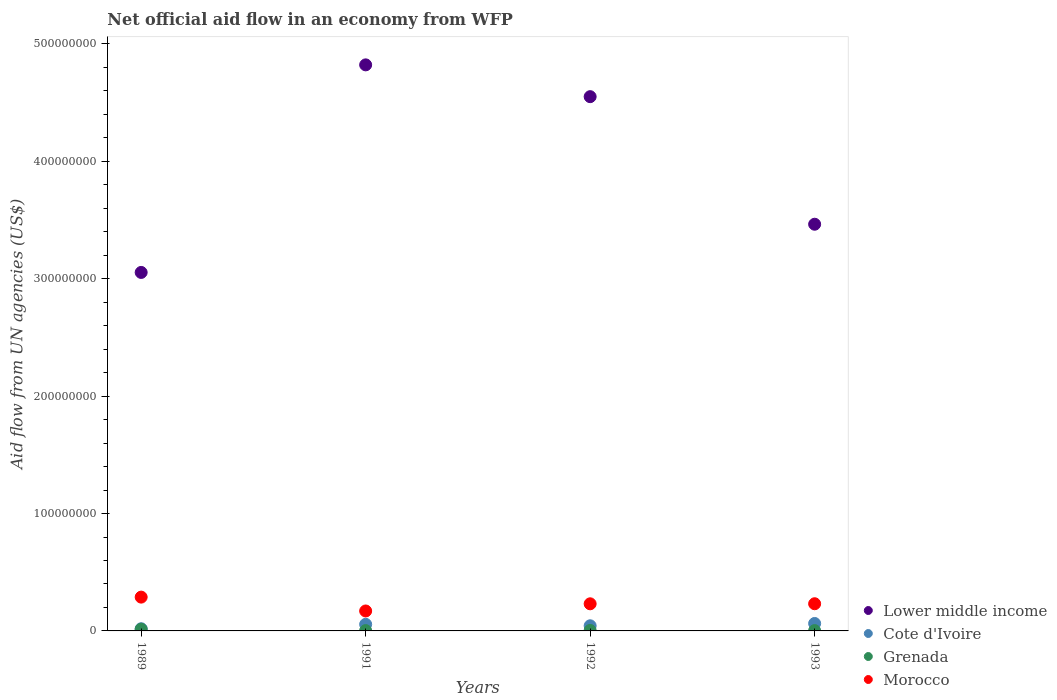How many different coloured dotlines are there?
Give a very brief answer. 4. Is the number of dotlines equal to the number of legend labels?
Keep it short and to the point. Yes. What is the net official aid flow in Lower middle income in 1993?
Make the answer very short. 3.46e+08. Across all years, what is the maximum net official aid flow in Morocco?
Your response must be concise. 2.88e+07. Across all years, what is the minimum net official aid flow in Morocco?
Ensure brevity in your answer.  1.70e+07. In which year was the net official aid flow in Lower middle income maximum?
Provide a short and direct response. 1991. In which year was the net official aid flow in Grenada minimum?
Offer a terse response. 1993. What is the total net official aid flow in Morocco in the graph?
Provide a succinct answer. 9.20e+07. What is the difference between the net official aid flow in Morocco in 1991 and that in 1993?
Offer a very short reply. -6.16e+06. What is the difference between the net official aid flow in Lower middle income in 1991 and the net official aid flow in Cote d'Ivoire in 1989?
Provide a short and direct response. 4.80e+08. What is the average net official aid flow in Lower middle income per year?
Provide a short and direct response. 3.97e+08. In the year 1991, what is the difference between the net official aid flow in Lower middle income and net official aid flow in Grenada?
Give a very brief answer. 4.82e+08. What is the ratio of the net official aid flow in Grenada in 1989 to that in 1991?
Your answer should be very brief. 5.14. What is the difference between the highest and the second highest net official aid flow in Cote d'Ivoire?
Give a very brief answer. 7.30e+05. What is the difference between the highest and the lowest net official aid flow in Lower middle income?
Your answer should be compact. 1.77e+08. Is the sum of the net official aid flow in Grenada in 1991 and 1993 greater than the maximum net official aid flow in Lower middle income across all years?
Your response must be concise. No. Is it the case that in every year, the sum of the net official aid flow in Cote d'Ivoire and net official aid flow in Morocco  is greater than the sum of net official aid flow in Lower middle income and net official aid flow in Grenada?
Your answer should be very brief. Yes. Does the net official aid flow in Morocco monotonically increase over the years?
Your answer should be very brief. No. Does the graph contain any zero values?
Offer a terse response. No. Does the graph contain grids?
Your answer should be very brief. No. Where does the legend appear in the graph?
Ensure brevity in your answer.  Bottom right. How are the legend labels stacked?
Make the answer very short. Vertical. What is the title of the graph?
Make the answer very short. Net official aid flow in an economy from WFP. Does "Tanzania" appear as one of the legend labels in the graph?
Keep it short and to the point. No. What is the label or title of the X-axis?
Provide a succinct answer. Years. What is the label or title of the Y-axis?
Your answer should be compact. Aid flow from UN agencies (US$). What is the Aid flow from UN agencies (US$) in Lower middle income in 1989?
Give a very brief answer. 3.05e+08. What is the Aid flow from UN agencies (US$) of Cote d'Ivoire in 1989?
Keep it short and to the point. 1.86e+06. What is the Aid flow from UN agencies (US$) in Grenada in 1989?
Your answer should be very brief. 1.44e+06. What is the Aid flow from UN agencies (US$) in Morocco in 1989?
Provide a short and direct response. 2.88e+07. What is the Aid flow from UN agencies (US$) of Lower middle income in 1991?
Provide a succinct answer. 4.82e+08. What is the Aid flow from UN agencies (US$) in Cote d'Ivoire in 1991?
Ensure brevity in your answer.  5.61e+06. What is the Aid flow from UN agencies (US$) of Morocco in 1991?
Offer a terse response. 1.70e+07. What is the Aid flow from UN agencies (US$) in Lower middle income in 1992?
Keep it short and to the point. 4.55e+08. What is the Aid flow from UN agencies (US$) of Cote d'Ivoire in 1992?
Offer a very short reply. 4.38e+06. What is the Aid flow from UN agencies (US$) of Grenada in 1992?
Offer a terse response. 4.20e+05. What is the Aid flow from UN agencies (US$) of Morocco in 1992?
Provide a succinct answer. 2.31e+07. What is the Aid flow from UN agencies (US$) in Lower middle income in 1993?
Provide a short and direct response. 3.46e+08. What is the Aid flow from UN agencies (US$) of Cote d'Ivoire in 1993?
Your answer should be compact. 6.34e+06. What is the Aid flow from UN agencies (US$) in Morocco in 1993?
Keep it short and to the point. 2.32e+07. Across all years, what is the maximum Aid flow from UN agencies (US$) in Lower middle income?
Keep it short and to the point. 4.82e+08. Across all years, what is the maximum Aid flow from UN agencies (US$) in Cote d'Ivoire?
Give a very brief answer. 6.34e+06. Across all years, what is the maximum Aid flow from UN agencies (US$) of Grenada?
Offer a terse response. 1.44e+06. Across all years, what is the maximum Aid flow from UN agencies (US$) of Morocco?
Ensure brevity in your answer.  2.88e+07. Across all years, what is the minimum Aid flow from UN agencies (US$) of Lower middle income?
Give a very brief answer. 3.05e+08. Across all years, what is the minimum Aid flow from UN agencies (US$) of Cote d'Ivoire?
Provide a short and direct response. 1.86e+06. Across all years, what is the minimum Aid flow from UN agencies (US$) of Morocco?
Your answer should be very brief. 1.70e+07. What is the total Aid flow from UN agencies (US$) of Lower middle income in the graph?
Offer a terse response. 1.59e+09. What is the total Aid flow from UN agencies (US$) in Cote d'Ivoire in the graph?
Offer a terse response. 1.82e+07. What is the total Aid flow from UN agencies (US$) in Grenada in the graph?
Your answer should be very brief. 2.41e+06. What is the total Aid flow from UN agencies (US$) of Morocco in the graph?
Your answer should be compact. 9.20e+07. What is the difference between the Aid flow from UN agencies (US$) of Lower middle income in 1989 and that in 1991?
Provide a short and direct response. -1.77e+08. What is the difference between the Aid flow from UN agencies (US$) in Cote d'Ivoire in 1989 and that in 1991?
Offer a very short reply. -3.75e+06. What is the difference between the Aid flow from UN agencies (US$) in Grenada in 1989 and that in 1991?
Offer a very short reply. 1.16e+06. What is the difference between the Aid flow from UN agencies (US$) of Morocco in 1989 and that in 1991?
Make the answer very short. 1.18e+07. What is the difference between the Aid flow from UN agencies (US$) of Lower middle income in 1989 and that in 1992?
Offer a terse response. -1.50e+08. What is the difference between the Aid flow from UN agencies (US$) in Cote d'Ivoire in 1989 and that in 1992?
Your answer should be compact. -2.52e+06. What is the difference between the Aid flow from UN agencies (US$) in Grenada in 1989 and that in 1992?
Give a very brief answer. 1.02e+06. What is the difference between the Aid flow from UN agencies (US$) in Morocco in 1989 and that in 1992?
Make the answer very short. 5.69e+06. What is the difference between the Aid flow from UN agencies (US$) in Lower middle income in 1989 and that in 1993?
Your response must be concise. -4.11e+07. What is the difference between the Aid flow from UN agencies (US$) in Cote d'Ivoire in 1989 and that in 1993?
Provide a short and direct response. -4.48e+06. What is the difference between the Aid flow from UN agencies (US$) of Grenada in 1989 and that in 1993?
Give a very brief answer. 1.17e+06. What is the difference between the Aid flow from UN agencies (US$) in Morocco in 1989 and that in 1993?
Your answer should be compact. 5.64e+06. What is the difference between the Aid flow from UN agencies (US$) in Lower middle income in 1991 and that in 1992?
Keep it short and to the point. 2.71e+07. What is the difference between the Aid flow from UN agencies (US$) of Cote d'Ivoire in 1991 and that in 1992?
Provide a succinct answer. 1.23e+06. What is the difference between the Aid flow from UN agencies (US$) in Morocco in 1991 and that in 1992?
Provide a short and direct response. -6.11e+06. What is the difference between the Aid flow from UN agencies (US$) of Lower middle income in 1991 and that in 1993?
Your answer should be very brief. 1.36e+08. What is the difference between the Aid flow from UN agencies (US$) in Cote d'Ivoire in 1991 and that in 1993?
Ensure brevity in your answer.  -7.30e+05. What is the difference between the Aid flow from UN agencies (US$) of Grenada in 1991 and that in 1993?
Ensure brevity in your answer.  10000. What is the difference between the Aid flow from UN agencies (US$) in Morocco in 1991 and that in 1993?
Your answer should be very brief. -6.16e+06. What is the difference between the Aid flow from UN agencies (US$) of Lower middle income in 1992 and that in 1993?
Keep it short and to the point. 1.09e+08. What is the difference between the Aid flow from UN agencies (US$) of Cote d'Ivoire in 1992 and that in 1993?
Keep it short and to the point. -1.96e+06. What is the difference between the Aid flow from UN agencies (US$) in Morocco in 1992 and that in 1993?
Keep it short and to the point. -5.00e+04. What is the difference between the Aid flow from UN agencies (US$) in Lower middle income in 1989 and the Aid flow from UN agencies (US$) in Cote d'Ivoire in 1991?
Your response must be concise. 3.00e+08. What is the difference between the Aid flow from UN agencies (US$) of Lower middle income in 1989 and the Aid flow from UN agencies (US$) of Grenada in 1991?
Ensure brevity in your answer.  3.05e+08. What is the difference between the Aid flow from UN agencies (US$) of Lower middle income in 1989 and the Aid flow from UN agencies (US$) of Morocco in 1991?
Ensure brevity in your answer.  2.88e+08. What is the difference between the Aid flow from UN agencies (US$) of Cote d'Ivoire in 1989 and the Aid flow from UN agencies (US$) of Grenada in 1991?
Provide a succinct answer. 1.58e+06. What is the difference between the Aid flow from UN agencies (US$) in Cote d'Ivoire in 1989 and the Aid flow from UN agencies (US$) in Morocco in 1991?
Provide a short and direct response. -1.51e+07. What is the difference between the Aid flow from UN agencies (US$) in Grenada in 1989 and the Aid flow from UN agencies (US$) in Morocco in 1991?
Make the answer very short. -1.56e+07. What is the difference between the Aid flow from UN agencies (US$) of Lower middle income in 1989 and the Aid flow from UN agencies (US$) of Cote d'Ivoire in 1992?
Make the answer very short. 3.01e+08. What is the difference between the Aid flow from UN agencies (US$) in Lower middle income in 1989 and the Aid flow from UN agencies (US$) in Grenada in 1992?
Provide a succinct answer. 3.05e+08. What is the difference between the Aid flow from UN agencies (US$) in Lower middle income in 1989 and the Aid flow from UN agencies (US$) in Morocco in 1992?
Your response must be concise. 2.82e+08. What is the difference between the Aid flow from UN agencies (US$) of Cote d'Ivoire in 1989 and the Aid flow from UN agencies (US$) of Grenada in 1992?
Ensure brevity in your answer.  1.44e+06. What is the difference between the Aid flow from UN agencies (US$) in Cote d'Ivoire in 1989 and the Aid flow from UN agencies (US$) in Morocco in 1992?
Provide a short and direct response. -2.12e+07. What is the difference between the Aid flow from UN agencies (US$) of Grenada in 1989 and the Aid flow from UN agencies (US$) of Morocco in 1992?
Offer a terse response. -2.17e+07. What is the difference between the Aid flow from UN agencies (US$) of Lower middle income in 1989 and the Aid flow from UN agencies (US$) of Cote d'Ivoire in 1993?
Provide a succinct answer. 2.99e+08. What is the difference between the Aid flow from UN agencies (US$) of Lower middle income in 1989 and the Aid flow from UN agencies (US$) of Grenada in 1993?
Keep it short and to the point. 3.05e+08. What is the difference between the Aid flow from UN agencies (US$) in Lower middle income in 1989 and the Aid flow from UN agencies (US$) in Morocco in 1993?
Your response must be concise. 2.82e+08. What is the difference between the Aid flow from UN agencies (US$) of Cote d'Ivoire in 1989 and the Aid flow from UN agencies (US$) of Grenada in 1993?
Provide a succinct answer. 1.59e+06. What is the difference between the Aid flow from UN agencies (US$) in Cote d'Ivoire in 1989 and the Aid flow from UN agencies (US$) in Morocco in 1993?
Your answer should be compact. -2.13e+07. What is the difference between the Aid flow from UN agencies (US$) in Grenada in 1989 and the Aid flow from UN agencies (US$) in Morocco in 1993?
Offer a terse response. -2.17e+07. What is the difference between the Aid flow from UN agencies (US$) of Lower middle income in 1991 and the Aid flow from UN agencies (US$) of Cote d'Ivoire in 1992?
Keep it short and to the point. 4.78e+08. What is the difference between the Aid flow from UN agencies (US$) of Lower middle income in 1991 and the Aid flow from UN agencies (US$) of Grenada in 1992?
Offer a very short reply. 4.82e+08. What is the difference between the Aid flow from UN agencies (US$) of Lower middle income in 1991 and the Aid flow from UN agencies (US$) of Morocco in 1992?
Give a very brief answer. 4.59e+08. What is the difference between the Aid flow from UN agencies (US$) in Cote d'Ivoire in 1991 and the Aid flow from UN agencies (US$) in Grenada in 1992?
Ensure brevity in your answer.  5.19e+06. What is the difference between the Aid flow from UN agencies (US$) in Cote d'Ivoire in 1991 and the Aid flow from UN agencies (US$) in Morocco in 1992?
Your response must be concise. -1.75e+07. What is the difference between the Aid flow from UN agencies (US$) in Grenada in 1991 and the Aid flow from UN agencies (US$) in Morocco in 1992?
Make the answer very short. -2.28e+07. What is the difference between the Aid flow from UN agencies (US$) of Lower middle income in 1991 and the Aid flow from UN agencies (US$) of Cote d'Ivoire in 1993?
Offer a terse response. 4.76e+08. What is the difference between the Aid flow from UN agencies (US$) in Lower middle income in 1991 and the Aid flow from UN agencies (US$) in Grenada in 1993?
Ensure brevity in your answer.  4.82e+08. What is the difference between the Aid flow from UN agencies (US$) of Lower middle income in 1991 and the Aid flow from UN agencies (US$) of Morocco in 1993?
Provide a short and direct response. 4.59e+08. What is the difference between the Aid flow from UN agencies (US$) in Cote d'Ivoire in 1991 and the Aid flow from UN agencies (US$) in Grenada in 1993?
Give a very brief answer. 5.34e+06. What is the difference between the Aid flow from UN agencies (US$) of Cote d'Ivoire in 1991 and the Aid flow from UN agencies (US$) of Morocco in 1993?
Provide a succinct answer. -1.75e+07. What is the difference between the Aid flow from UN agencies (US$) of Grenada in 1991 and the Aid flow from UN agencies (US$) of Morocco in 1993?
Ensure brevity in your answer.  -2.29e+07. What is the difference between the Aid flow from UN agencies (US$) in Lower middle income in 1992 and the Aid flow from UN agencies (US$) in Cote d'Ivoire in 1993?
Your answer should be very brief. 4.49e+08. What is the difference between the Aid flow from UN agencies (US$) in Lower middle income in 1992 and the Aid flow from UN agencies (US$) in Grenada in 1993?
Offer a terse response. 4.55e+08. What is the difference between the Aid flow from UN agencies (US$) of Lower middle income in 1992 and the Aid flow from UN agencies (US$) of Morocco in 1993?
Your answer should be very brief. 4.32e+08. What is the difference between the Aid flow from UN agencies (US$) of Cote d'Ivoire in 1992 and the Aid flow from UN agencies (US$) of Grenada in 1993?
Give a very brief answer. 4.11e+06. What is the difference between the Aid flow from UN agencies (US$) of Cote d'Ivoire in 1992 and the Aid flow from UN agencies (US$) of Morocco in 1993?
Your answer should be compact. -1.88e+07. What is the difference between the Aid flow from UN agencies (US$) in Grenada in 1992 and the Aid flow from UN agencies (US$) in Morocco in 1993?
Your answer should be compact. -2.27e+07. What is the average Aid flow from UN agencies (US$) of Lower middle income per year?
Make the answer very short. 3.97e+08. What is the average Aid flow from UN agencies (US$) in Cote d'Ivoire per year?
Keep it short and to the point. 4.55e+06. What is the average Aid flow from UN agencies (US$) in Grenada per year?
Give a very brief answer. 6.02e+05. What is the average Aid flow from UN agencies (US$) of Morocco per year?
Your response must be concise. 2.30e+07. In the year 1989, what is the difference between the Aid flow from UN agencies (US$) of Lower middle income and Aid flow from UN agencies (US$) of Cote d'Ivoire?
Your answer should be very brief. 3.04e+08. In the year 1989, what is the difference between the Aid flow from UN agencies (US$) of Lower middle income and Aid flow from UN agencies (US$) of Grenada?
Offer a terse response. 3.04e+08. In the year 1989, what is the difference between the Aid flow from UN agencies (US$) in Lower middle income and Aid flow from UN agencies (US$) in Morocco?
Your answer should be compact. 2.77e+08. In the year 1989, what is the difference between the Aid flow from UN agencies (US$) in Cote d'Ivoire and Aid flow from UN agencies (US$) in Grenada?
Ensure brevity in your answer.  4.20e+05. In the year 1989, what is the difference between the Aid flow from UN agencies (US$) of Cote d'Ivoire and Aid flow from UN agencies (US$) of Morocco?
Keep it short and to the point. -2.69e+07. In the year 1989, what is the difference between the Aid flow from UN agencies (US$) in Grenada and Aid flow from UN agencies (US$) in Morocco?
Offer a terse response. -2.74e+07. In the year 1991, what is the difference between the Aid flow from UN agencies (US$) in Lower middle income and Aid flow from UN agencies (US$) in Cote d'Ivoire?
Give a very brief answer. 4.77e+08. In the year 1991, what is the difference between the Aid flow from UN agencies (US$) of Lower middle income and Aid flow from UN agencies (US$) of Grenada?
Provide a short and direct response. 4.82e+08. In the year 1991, what is the difference between the Aid flow from UN agencies (US$) of Lower middle income and Aid flow from UN agencies (US$) of Morocco?
Offer a terse response. 4.65e+08. In the year 1991, what is the difference between the Aid flow from UN agencies (US$) in Cote d'Ivoire and Aid flow from UN agencies (US$) in Grenada?
Your answer should be very brief. 5.33e+06. In the year 1991, what is the difference between the Aid flow from UN agencies (US$) in Cote d'Ivoire and Aid flow from UN agencies (US$) in Morocco?
Ensure brevity in your answer.  -1.14e+07. In the year 1991, what is the difference between the Aid flow from UN agencies (US$) in Grenada and Aid flow from UN agencies (US$) in Morocco?
Your answer should be very brief. -1.67e+07. In the year 1992, what is the difference between the Aid flow from UN agencies (US$) in Lower middle income and Aid flow from UN agencies (US$) in Cote d'Ivoire?
Offer a terse response. 4.51e+08. In the year 1992, what is the difference between the Aid flow from UN agencies (US$) in Lower middle income and Aid flow from UN agencies (US$) in Grenada?
Offer a terse response. 4.55e+08. In the year 1992, what is the difference between the Aid flow from UN agencies (US$) of Lower middle income and Aid flow from UN agencies (US$) of Morocco?
Make the answer very short. 4.32e+08. In the year 1992, what is the difference between the Aid flow from UN agencies (US$) of Cote d'Ivoire and Aid flow from UN agencies (US$) of Grenada?
Provide a succinct answer. 3.96e+06. In the year 1992, what is the difference between the Aid flow from UN agencies (US$) of Cote d'Ivoire and Aid flow from UN agencies (US$) of Morocco?
Offer a very short reply. -1.87e+07. In the year 1992, what is the difference between the Aid flow from UN agencies (US$) in Grenada and Aid flow from UN agencies (US$) in Morocco?
Your answer should be compact. -2.27e+07. In the year 1993, what is the difference between the Aid flow from UN agencies (US$) in Lower middle income and Aid flow from UN agencies (US$) in Cote d'Ivoire?
Your answer should be compact. 3.40e+08. In the year 1993, what is the difference between the Aid flow from UN agencies (US$) of Lower middle income and Aid flow from UN agencies (US$) of Grenada?
Offer a terse response. 3.46e+08. In the year 1993, what is the difference between the Aid flow from UN agencies (US$) in Lower middle income and Aid flow from UN agencies (US$) in Morocco?
Provide a succinct answer. 3.23e+08. In the year 1993, what is the difference between the Aid flow from UN agencies (US$) in Cote d'Ivoire and Aid flow from UN agencies (US$) in Grenada?
Your answer should be very brief. 6.07e+06. In the year 1993, what is the difference between the Aid flow from UN agencies (US$) in Cote d'Ivoire and Aid flow from UN agencies (US$) in Morocco?
Keep it short and to the point. -1.68e+07. In the year 1993, what is the difference between the Aid flow from UN agencies (US$) of Grenada and Aid flow from UN agencies (US$) of Morocco?
Provide a succinct answer. -2.29e+07. What is the ratio of the Aid flow from UN agencies (US$) of Lower middle income in 1989 to that in 1991?
Provide a short and direct response. 0.63. What is the ratio of the Aid flow from UN agencies (US$) of Cote d'Ivoire in 1989 to that in 1991?
Ensure brevity in your answer.  0.33. What is the ratio of the Aid flow from UN agencies (US$) in Grenada in 1989 to that in 1991?
Give a very brief answer. 5.14. What is the ratio of the Aid flow from UN agencies (US$) in Morocco in 1989 to that in 1991?
Offer a very short reply. 1.69. What is the ratio of the Aid flow from UN agencies (US$) in Lower middle income in 1989 to that in 1992?
Your answer should be compact. 0.67. What is the ratio of the Aid flow from UN agencies (US$) of Cote d'Ivoire in 1989 to that in 1992?
Your response must be concise. 0.42. What is the ratio of the Aid flow from UN agencies (US$) in Grenada in 1989 to that in 1992?
Provide a short and direct response. 3.43. What is the ratio of the Aid flow from UN agencies (US$) of Morocco in 1989 to that in 1992?
Keep it short and to the point. 1.25. What is the ratio of the Aid flow from UN agencies (US$) in Lower middle income in 1989 to that in 1993?
Keep it short and to the point. 0.88. What is the ratio of the Aid flow from UN agencies (US$) in Cote d'Ivoire in 1989 to that in 1993?
Offer a very short reply. 0.29. What is the ratio of the Aid flow from UN agencies (US$) in Grenada in 1989 to that in 1993?
Your answer should be compact. 5.33. What is the ratio of the Aid flow from UN agencies (US$) of Morocco in 1989 to that in 1993?
Keep it short and to the point. 1.24. What is the ratio of the Aid flow from UN agencies (US$) of Lower middle income in 1991 to that in 1992?
Your answer should be very brief. 1.06. What is the ratio of the Aid flow from UN agencies (US$) in Cote d'Ivoire in 1991 to that in 1992?
Ensure brevity in your answer.  1.28. What is the ratio of the Aid flow from UN agencies (US$) of Grenada in 1991 to that in 1992?
Keep it short and to the point. 0.67. What is the ratio of the Aid flow from UN agencies (US$) of Morocco in 1991 to that in 1992?
Offer a terse response. 0.74. What is the ratio of the Aid flow from UN agencies (US$) of Lower middle income in 1991 to that in 1993?
Make the answer very short. 1.39. What is the ratio of the Aid flow from UN agencies (US$) in Cote d'Ivoire in 1991 to that in 1993?
Provide a succinct answer. 0.88. What is the ratio of the Aid flow from UN agencies (US$) in Morocco in 1991 to that in 1993?
Provide a succinct answer. 0.73. What is the ratio of the Aid flow from UN agencies (US$) in Lower middle income in 1992 to that in 1993?
Offer a terse response. 1.31. What is the ratio of the Aid flow from UN agencies (US$) in Cote d'Ivoire in 1992 to that in 1993?
Make the answer very short. 0.69. What is the ratio of the Aid flow from UN agencies (US$) of Grenada in 1992 to that in 1993?
Your answer should be very brief. 1.56. What is the difference between the highest and the second highest Aid flow from UN agencies (US$) in Lower middle income?
Offer a very short reply. 2.71e+07. What is the difference between the highest and the second highest Aid flow from UN agencies (US$) of Cote d'Ivoire?
Make the answer very short. 7.30e+05. What is the difference between the highest and the second highest Aid flow from UN agencies (US$) in Grenada?
Your answer should be compact. 1.02e+06. What is the difference between the highest and the second highest Aid flow from UN agencies (US$) in Morocco?
Your response must be concise. 5.64e+06. What is the difference between the highest and the lowest Aid flow from UN agencies (US$) in Lower middle income?
Your answer should be very brief. 1.77e+08. What is the difference between the highest and the lowest Aid flow from UN agencies (US$) of Cote d'Ivoire?
Keep it short and to the point. 4.48e+06. What is the difference between the highest and the lowest Aid flow from UN agencies (US$) of Grenada?
Provide a succinct answer. 1.17e+06. What is the difference between the highest and the lowest Aid flow from UN agencies (US$) of Morocco?
Offer a very short reply. 1.18e+07. 